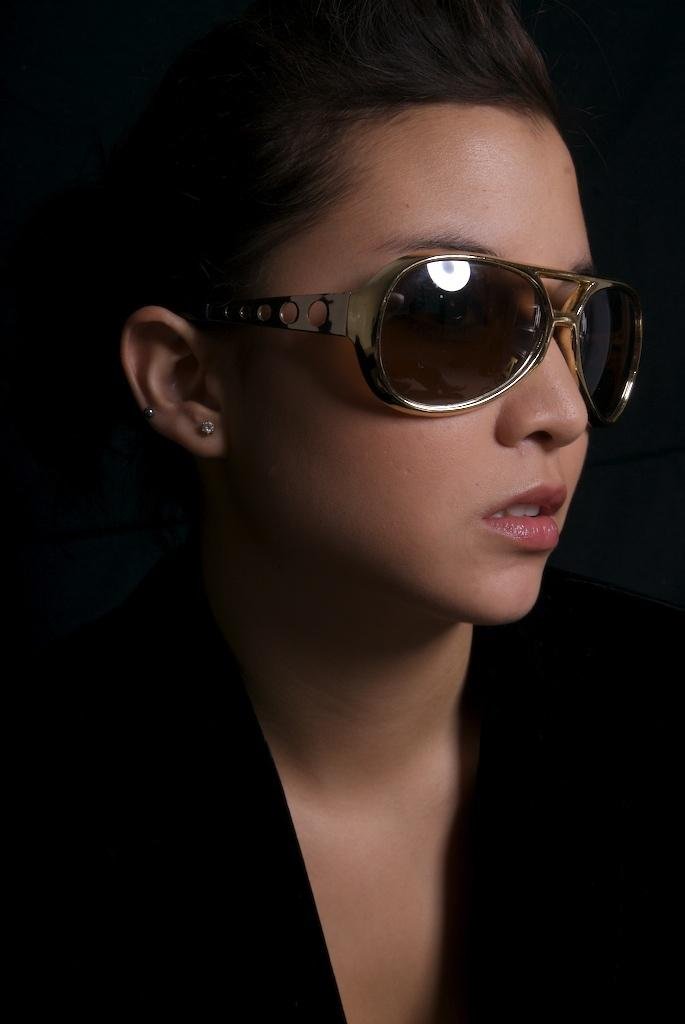Who is present in the image? There is a woman in the image. What is the woman wearing? The woman is wearing clothes, goggles, and earring studs. What type of trucks can be seen in the image? There are no trucks present in the image; it features a woman wearing clothes, goggles, and earring studs. 